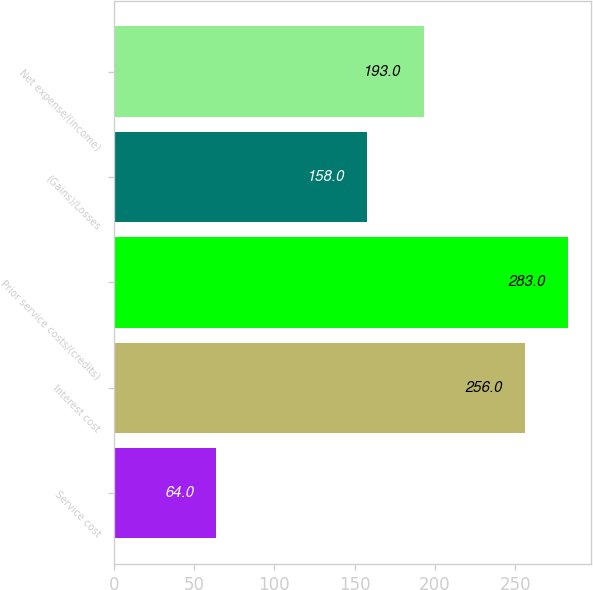<chart> <loc_0><loc_0><loc_500><loc_500><bar_chart><fcel>Service cost<fcel>Interest cost<fcel>Prior service costs/(credits)<fcel>(Gains)/Losses<fcel>Net expense/(income)<nl><fcel>64<fcel>256<fcel>283<fcel>158<fcel>193<nl></chart> 